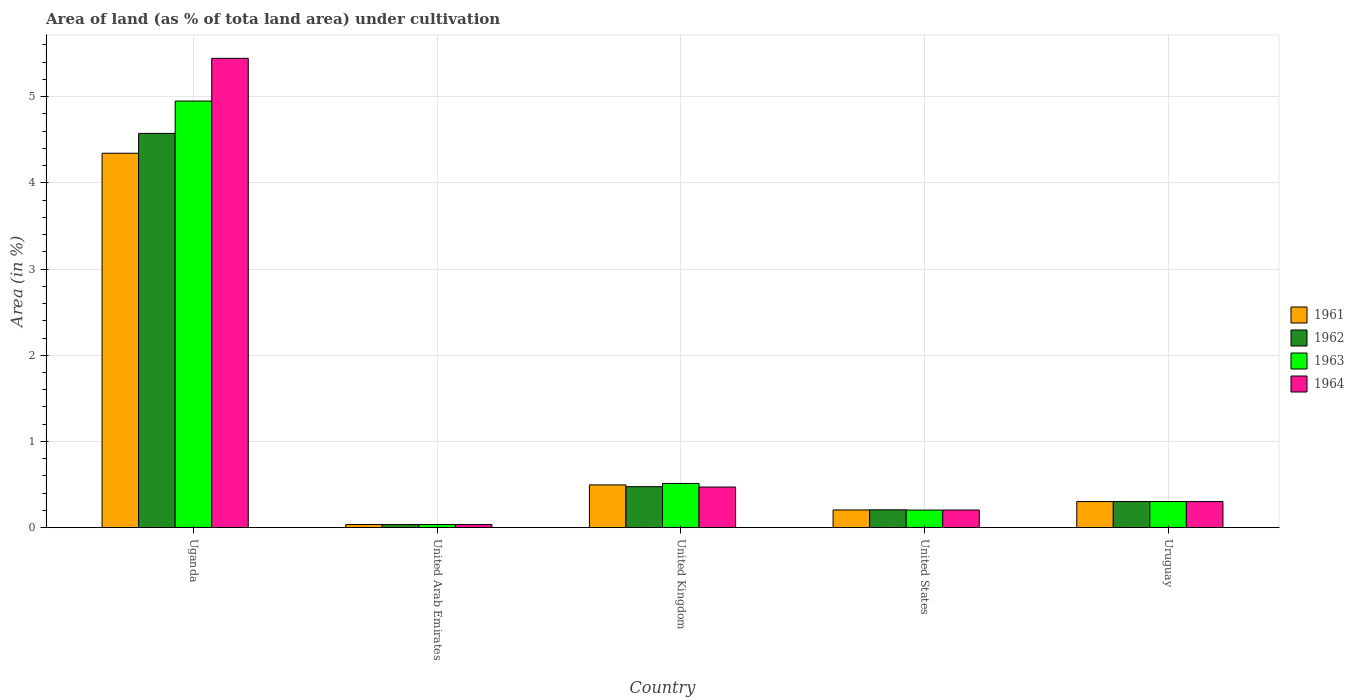How many different coloured bars are there?
Provide a short and direct response. 4. How many groups of bars are there?
Ensure brevity in your answer.  5. Are the number of bars per tick equal to the number of legend labels?
Offer a terse response. Yes. Are the number of bars on each tick of the X-axis equal?
Offer a very short reply. Yes. How many bars are there on the 3rd tick from the left?
Your answer should be compact. 4. What is the label of the 5th group of bars from the left?
Offer a terse response. Uruguay. In how many cases, is the number of bars for a given country not equal to the number of legend labels?
Ensure brevity in your answer.  0. What is the percentage of land under cultivation in 1963 in United Arab Emirates?
Your answer should be compact. 0.04. Across all countries, what is the maximum percentage of land under cultivation in 1963?
Offer a very short reply. 4.95. Across all countries, what is the minimum percentage of land under cultivation in 1964?
Provide a short and direct response. 0.04. In which country was the percentage of land under cultivation in 1962 maximum?
Provide a short and direct response. Uganda. In which country was the percentage of land under cultivation in 1962 minimum?
Make the answer very short. United Arab Emirates. What is the total percentage of land under cultivation in 1964 in the graph?
Offer a very short reply. 6.46. What is the difference between the percentage of land under cultivation in 1964 in Uganda and that in Uruguay?
Keep it short and to the point. 5.14. What is the difference between the percentage of land under cultivation in 1961 in Uganda and the percentage of land under cultivation in 1963 in United States?
Provide a succinct answer. 4.14. What is the average percentage of land under cultivation in 1964 per country?
Your answer should be compact. 1.29. In how many countries, is the percentage of land under cultivation in 1961 greater than 4.8 %?
Ensure brevity in your answer.  0. What is the ratio of the percentage of land under cultivation in 1964 in United Kingdom to that in Uruguay?
Provide a succinct answer. 1.56. Is the percentage of land under cultivation in 1963 in Uganda less than that in United States?
Provide a succinct answer. No. Is the difference between the percentage of land under cultivation in 1962 in Uganda and United Kingdom greater than the difference between the percentage of land under cultivation in 1964 in Uganda and United Kingdom?
Your response must be concise. No. What is the difference between the highest and the second highest percentage of land under cultivation in 1962?
Ensure brevity in your answer.  0.17. What is the difference between the highest and the lowest percentage of land under cultivation in 1961?
Keep it short and to the point. 4.31. Is the sum of the percentage of land under cultivation in 1962 in United Arab Emirates and United Kingdom greater than the maximum percentage of land under cultivation in 1963 across all countries?
Your answer should be very brief. No. What does the 2nd bar from the left in United Kingdom represents?
Make the answer very short. 1962. What does the 1st bar from the right in United States represents?
Provide a succinct answer. 1964. How many bars are there?
Your answer should be very brief. 20. How many legend labels are there?
Your answer should be compact. 4. How are the legend labels stacked?
Keep it short and to the point. Vertical. What is the title of the graph?
Your answer should be very brief. Area of land (as % of tota land area) under cultivation. Does "1976" appear as one of the legend labels in the graph?
Offer a very short reply. No. What is the label or title of the X-axis?
Ensure brevity in your answer.  Country. What is the label or title of the Y-axis?
Keep it short and to the point. Area (in %). What is the Area (in %) in 1961 in Uganda?
Give a very brief answer. 4.34. What is the Area (in %) in 1962 in Uganda?
Your answer should be very brief. 4.57. What is the Area (in %) in 1963 in Uganda?
Your answer should be compact. 4.95. What is the Area (in %) in 1964 in Uganda?
Your response must be concise. 5.45. What is the Area (in %) of 1961 in United Arab Emirates?
Give a very brief answer. 0.04. What is the Area (in %) of 1962 in United Arab Emirates?
Provide a short and direct response. 0.04. What is the Area (in %) of 1963 in United Arab Emirates?
Give a very brief answer. 0.04. What is the Area (in %) in 1964 in United Arab Emirates?
Offer a terse response. 0.04. What is the Area (in %) of 1961 in United Kingdom?
Your answer should be very brief. 0.5. What is the Area (in %) in 1962 in United Kingdom?
Provide a succinct answer. 0.48. What is the Area (in %) in 1963 in United Kingdom?
Ensure brevity in your answer.  0.51. What is the Area (in %) of 1964 in United Kingdom?
Keep it short and to the point. 0.47. What is the Area (in %) in 1961 in United States?
Your answer should be very brief. 0.21. What is the Area (in %) of 1962 in United States?
Your answer should be compact. 0.21. What is the Area (in %) in 1963 in United States?
Give a very brief answer. 0.2. What is the Area (in %) of 1964 in United States?
Offer a terse response. 0.2. What is the Area (in %) of 1961 in Uruguay?
Your answer should be compact. 0.3. What is the Area (in %) of 1962 in Uruguay?
Offer a terse response. 0.3. What is the Area (in %) of 1963 in Uruguay?
Make the answer very short. 0.3. What is the Area (in %) in 1964 in Uruguay?
Give a very brief answer. 0.3. Across all countries, what is the maximum Area (in %) in 1961?
Provide a succinct answer. 4.34. Across all countries, what is the maximum Area (in %) of 1962?
Your response must be concise. 4.57. Across all countries, what is the maximum Area (in %) of 1963?
Provide a short and direct response. 4.95. Across all countries, what is the maximum Area (in %) in 1964?
Offer a terse response. 5.45. Across all countries, what is the minimum Area (in %) of 1961?
Give a very brief answer. 0.04. Across all countries, what is the minimum Area (in %) in 1962?
Give a very brief answer. 0.04. Across all countries, what is the minimum Area (in %) of 1963?
Provide a succinct answer. 0.04. Across all countries, what is the minimum Area (in %) of 1964?
Provide a succinct answer. 0.04. What is the total Area (in %) of 1961 in the graph?
Keep it short and to the point. 5.38. What is the total Area (in %) in 1962 in the graph?
Offer a very short reply. 5.6. What is the total Area (in %) of 1963 in the graph?
Provide a succinct answer. 6. What is the total Area (in %) of 1964 in the graph?
Your response must be concise. 6.46. What is the difference between the Area (in %) of 1961 in Uganda and that in United Arab Emirates?
Your answer should be compact. 4.31. What is the difference between the Area (in %) in 1962 in Uganda and that in United Arab Emirates?
Your answer should be very brief. 4.54. What is the difference between the Area (in %) in 1963 in Uganda and that in United Arab Emirates?
Provide a short and direct response. 4.91. What is the difference between the Area (in %) in 1964 in Uganda and that in United Arab Emirates?
Provide a succinct answer. 5.41. What is the difference between the Area (in %) in 1961 in Uganda and that in United Kingdom?
Provide a short and direct response. 3.85. What is the difference between the Area (in %) in 1962 in Uganda and that in United Kingdom?
Ensure brevity in your answer.  4.1. What is the difference between the Area (in %) in 1963 in Uganda and that in United Kingdom?
Your response must be concise. 4.44. What is the difference between the Area (in %) in 1964 in Uganda and that in United Kingdom?
Give a very brief answer. 4.97. What is the difference between the Area (in %) of 1961 in Uganda and that in United States?
Your answer should be very brief. 4.14. What is the difference between the Area (in %) in 1962 in Uganda and that in United States?
Your response must be concise. 4.37. What is the difference between the Area (in %) in 1963 in Uganda and that in United States?
Your response must be concise. 4.75. What is the difference between the Area (in %) in 1964 in Uganda and that in United States?
Provide a short and direct response. 5.24. What is the difference between the Area (in %) of 1961 in Uganda and that in Uruguay?
Keep it short and to the point. 4.04. What is the difference between the Area (in %) of 1962 in Uganda and that in Uruguay?
Your answer should be compact. 4.27. What is the difference between the Area (in %) of 1963 in Uganda and that in Uruguay?
Offer a very short reply. 4.65. What is the difference between the Area (in %) in 1964 in Uganda and that in Uruguay?
Your answer should be very brief. 5.14. What is the difference between the Area (in %) of 1961 in United Arab Emirates and that in United Kingdom?
Offer a very short reply. -0.46. What is the difference between the Area (in %) in 1962 in United Arab Emirates and that in United Kingdom?
Your answer should be compact. -0.44. What is the difference between the Area (in %) of 1963 in United Arab Emirates and that in United Kingdom?
Your answer should be compact. -0.48. What is the difference between the Area (in %) in 1964 in United Arab Emirates and that in United Kingdom?
Provide a succinct answer. -0.44. What is the difference between the Area (in %) of 1961 in United Arab Emirates and that in United States?
Your answer should be very brief. -0.17. What is the difference between the Area (in %) of 1962 in United Arab Emirates and that in United States?
Give a very brief answer. -0.17. What is the difference between the Area (in %) of 1963 in United Arab Emirates and that in United States?
Your answer should be compact. -0.17. What is the difference between the Area (in %) in 1964 in United Arab Emirates and that in United States?
Give a very brief answer. -0.17. What is the difference between the Area (in %) in 1961 in United Arab Emirates and that in Uruguay?
Your response must be concise. -0.27. What is the difference between the Area (in %) in 1962 in United Arab Emirates and that in Uruguay?
Ensure brevity in your answer.  -0.27. What is the difference between the Area (in %) of 1963 in United Arab Emirates and that in Uruguay?
Your answer should be compact. -0.27. What is the difference between the Area (in %) of 1964 in United Arab Emirates and that in Uruguay?
Provide a short and direct response. -0.27. What is the difference between the Area (in %) in 1961 in United Kingdom and that in United States?
Give a very brief answer. 0.29. What is the difference between the Area (in %) in 1962 in United Kingdom and that in United States?
Keep it short and to the point. 0.27. What is the difference between the Area (in %) of 1963 in United Kingdom and that in United States?
Your response must be concise. 0.31. What is the difference between the Area (in %) in 1964 in United Kingdom and that in United States?
Give a very brief answer. 0.27. What is the difference between the Area (in %) of 1961 in United Kingdom and that in Uruguay?
Provide a succinct answer. 0.19. What is the difference between the Area (in %) in 1962 in United Kingdom and that in Uruguay?
Your answer should be compact. 0.17. What is the difference between the Area (in %) in 1963 in United Kingdom and that in Uruguay?
Ensure brevity in your answer.  0.21. What is the difference between the Area (in %) of 1964 in United Kingdom and that in Uruguay?
Your answer should be compact. 0.17. What is the difference between the Area (in %) of 1961 in United States and that in Uruguay?
Offer a very short reply. -0.1. What is the difference between the Area (in %) in 1962 in United States and that in Uruguay?
Provide a succinct answer. -0.1. What is the difference between the Area (in %) of 1963 in United States and that in Uruguay?
Make the answer very short. -0.1. What is the difference between the Area (in %) in 1964 in United States and that in Uruguay?
Make the answer very short. -0.1. What is the difference between the Area (in %) in 1961 in Uganda and the Area (in %) in 1962 in United Arab Emirates?
Your answer should be very brief. 4.31. What is the difference between the Area (in %) in 1961 in Uganda and the Area (in %) in 1963 in United Arab Emirates?
Make the answer very short. 4.31. What is the difference between the Area (in %) of 1961 in Uganda and the Area (in %) of 1964 in United Arab Emirates?
Provide a short and direct response. 4.31. What is the difference between the Area (in %) of 1962 in Uganda and the Area (in %) of 1963 in United Arab Emirates?
Your response must be concise. 4.54. What is the difference between the Area (in %) of 1962 in Uganda and the Area (in %) of 1964 in United Arab Emirates?
Make the answer very short. 4.54. What is the difference between the Area (in %) in 1963 in Uganda and the Area (in %) in 1964 in United Arab Emirates?
Ensure brevity in your answer.  4.91. What is the difference between the Area (in %) of 1961 in Uganda and the Area (in %) of 1962 in United Kingdom?
Keep it short and to the point. 3.87. What is the difference between the Area (in %) in 1961 in Uganda and the Area (in %) in 1963 in United Kingdom?
Provide a short and direct response. 3.83. What is the difference between the Area (in %) of 1961 in Uganda and the Area (in %) of 1964 in United Kingdom?
Provide a succinct answer. 3.87. What is the difference between the Area (in %) in 1962 in Uganda and the Area (in %) in 1963 in United Kingdom?
Your answer should be very brief. 4.06. What is the difference between the Area (in %) in 1962 in Uganda and the Area (in %) in 1964 in United Kingdom?
Provide a succinct answer. 4.1. What is the difference between the Area (in %) of 1963 in Uganda and the Area (in %) of 1964 in United Kingdom?
Offer a terse response. 4.48. What is the difference between the Area (in %) of 1961 in Uganda and the Area (in %) of 1962 in United States?
Offer a terse response. 4.14. What is the difference between the Area (in %) of 1961 in Uganda and the Area (in %) of 1963 in United States?
Provide a succinct answer. 4.14. What is the difference between the Area (in %) in 1961 in Uganda and the Area (in %) in 1964 in United States?
Provide a succinct answer. 4.14. What is the difference between the Area (in %) of 1962 in Uganda and the Area (in %) of 1963 in United States?
Give a very brief answer. 4.37. What is the difference between the Area (in %) of 1962 in Uganda and the Area (in %) of 1964 in United States?
Your response must be concise. 4.37. What is the difference between the Area (in %) of 1963 in Uganda and the Area (in %) of 1964 in United States?
Provide a short and direct response. 4.75. What is the difference between the Area (in %) of 1961 in Uganda and the Area (in %) of 1962 in Uruguay?
Your answer should be very brief. 4.04. What is the difference between the Area (in %) in 1961 in Uganda and the Area (in %) in 1963 in Uruguay?
Ensure brevity in your answer.  4.04. What is the difference between the Area (in %) of 1961 in Uganda and the Area (in %) of 1964 in Uruguay?
Provide a short and direct response. 4.04. What is the difference between the Area (in %) in 1962 in Uganda and the Area (in %) in 1963 in Uruguay?
Ensure brevity in your answer.  4.27. What is the difference between the Area (in %) of 1962 in Uganda and the Area (in %) of 1964 in Uruguay?
Give a very brief answer. 4.27. What is the difference between the Area (in %) of 1963 in Uganda and the Area (in %) of 1964 in Uruguay?
Ensure brevity in your answer.  4.65. What is the difference between the Area (in %) of 1961 in United Arab Emirates and the Area (in %) of 1962 in United Kingdom?
Your answer should be compact. -0.44. What is the difference between the Area (in %) in 1961 in United Arab Emirates and the Area (in %) in 1963 in United Kingdom?
Provide a short and direct response. -0.48. What is the difference between the Area (in %) in 1961 in United Arab Emirates and the Area (in %) in 1964 in United Kingdom?
Offer a very short reply. -0.44. What is the difference between the Area (in %) in 1962 in United Arab Emirates and the Area (in %) in 1963 in United Kingdom?
Your response must be concise. -0.48. What is the difference between the Area (in %) of 1962 in United Arab Emirates and the Area (in %) of 1964 in United Kingdom?
Provide a short and direct response. -0.44. What is the difference between the Area (in %) in 1963 in United Arab Emirates and the Area (in %) in 1964 in United Kingdom?
Provide a succinct answer. -0.44. What is the difference between the Area (in %) in 1961 in United Arab Emirates and the Area (in %) in 1962 in United States?
Your answer should be very brief. -0.17. What is the difference between the Area (in %) in 1961 in United Arab Emirates and the Area (in %) in 1963 in United States?
Provide a short and direct response. -0.17. What is the difference between the Area (in %) of 1961 in United Arab Emirates and the Area (in %) of 1964 in United States?
Your response must be concise. -0.17. What is the difference between the Area (in %) of 1962 in United Arab Emirates and the Area (in %) of 1963 in United States?
Provide a short and direct response. -0.17. What is the difference between the Area (in %) of 1962 in United Arab Emirates and the Area (in %) of 1964 in United States?
Make the answer very short. -0.17. What is the difference between the Area (in %) of 1963 in United Arab Emirates and the Area (in %) of 1964 in United States?
Make the answer very short. -0.17. What is the difference between the Area (in %) in 1961 in United Arab Emirates and the Area (in %) in 1962 in Uruguay?
Offer a terse response. -0.27. What is the difference between the Area (in %) in 1961 in United Arab Emirates and the Area (in %) in 1963 in Uruguay?
Ensure brevity in your answer.  -0.27. What is the difference between the Area (in %) of 1961 in United Arab Emirates and the Area (in %) of 1964 in Uruguay?
Your answer should be compact. -0.27. What is the difference between the Area (in %) in 1962 in United Arab Emirates and the Area (in %) in 1963 in Uruguay?
Your answer should be compact. -0.27. What is the difference between the Area (in %) of 1962 in United Arab Emirates and the Area (in %) of 1964 in Uruguay?
Your answer should be compact. -0.27. What is the difference between the Area (in %) in 1963 in United Arab Emirates and the Area (in %) in 1964 in Uruguay?
Give a very brief answer. -0.27. What is the difference between the Area (in %) of 1961 in United Kingdom and the Area (in %) of 1962 in United States?
Offer a very short reply. 0.29. What is the difference between the Area (in %) in 1961 in United Kingdom and the Area (in %) in 1963 in United States?
Provide a short and direct response. 0.29. What is the difference between the Area (in %) in 1961 in United Kingdom and the Area (in %) in 1964 in United States?
Ensure brevity in your answer.  0.29. What is the difference between the Area (in %) in 1962 in United Kingdom and the Area (in %) in 1963 in United States?
Your response must be concise. 0.27. What is the difference between the Area (in %) in 1962 in United Kingdom and the Area (in %) in 1964 in United States?
Your answer should be very brief. 0.27. What is the difference between the Area (in %) of 1963 in United Kingdom and the Area (in %) of 1964 in United States?
Provide a succinct answer. 0.31. What is the difference between the Area (in %) of 1961 in United Kingdom and the Area (in %) of 1962 in Uruguay?
Your answer should be very brief. 0.19. What is the difference between the Area (in %) of 1961 in United Kingdom and the Area (in %) of 1963 in Uruguay?
Keep it short and to the point. 0.19. What is the difference between the Area (in %) in 1961 in United Kingdom and the Area (in %) in 1964 in Uruguay?
Make the answer very short. 0.19. What is the difference between the Area (in %) in 1962 in United Kingdom and the Area (in %) in 1963 in Uruguay?
Offer a terse response. 0.17. What is the difference between the Area (in %) in 1962 in United Kingdom and the Area (in %) in 1964 in Uruguay?
Provide a succinct answer. 0.17. What is the difference between the Area (in %) in 1963 in United Kingdom and the Area (in %) in 1964 in Uruguay?
Your answer should be very brief. 0.21. What is the difference between the Area (in %) of 1961 in United States and the Area (in %) of 1962 in Uruguay?
Ensure brevity in your answer.  -0.1. What is the difference between the Area (in %) of 1961 in United States and the Area (in %) of 1963 in Uruguay?
Your answer should be compact. -0.1. What is the difference between the Area (in %) of 1961 in United States and the Area (in %) of 1964 in Uruguay?
Provide a short and direct response. -0.1. What is the difference between the Area (in %) in 1962 in United States and the Area (in %) in 1963 in Uruguay?
Keep it short and to the point. -0.1. What is the difference between the Area (in %) in 1962 in United States and the Area (in %) in 1964 in Uruguay?
Offer a terse response. -0.1. What is the difference between the Area (in %) in 1963 in United States and the Area (in %) in 1964 in Uruguay?
Provide a succinct answer. -0.1. What is the average Area (in %) of 1961 per country?
Provide a short and direct response. 1.08. What is the average Area (in %) of 1962 per country?
Your answer should be very brief. 1.12. What is the average Area (in %) of 1963 per country?
Provide a short and direct response. 1.2. What is the average Area (in %) of 1964 per country?
Your answer should be compact. 1.29. What is the difference between the Area (in %) in 1961 and Area (in %) in 1962 in Uganda?
Make the answer very short. -0.23. What is the difference between the Area (in %) in 1961 and Area (in %) in 1963 in Uganda?
Give a very brief answer. -0.61. What is the difference between the Area (in %) of 1961 and Area (in %) of 1964 in Uganda?
Make the answer very short. -1.1. What is the difference between the Area (in %) of 1962 and Area (in %) of 1963 in Uganda?
Provide a short and direct response. -0.38. What is the difference between the Area (in %) of 1962 and Area (in %) of 1964 in Uganda?
Your response must be concise. -0.87. What is the difference between the Area (in %) in 1963 and Area (in %) in 1964 in Uganda?
Give a very brief answer. -0.5. What is the difference between the Area (in %) in 1961 and Area (in %) in 1964 in United Arab Emirates?
Offer a very short reply. 0. What is the difference between the Area (in %) of 1962 and Area (in %) of 1963 in United Arab Emirates?
Offer a very short reply. 0. What is the difference between the Area (in %) of 1961 and Area (in %) of 1962 in United Kingdom?
Provide a succinct answer. 0.02. What is the difference between the Area (in %) of 1961 and Area (in %) of 1963 in United Kingdom?
Your answer should be very brief. -0.02. What is the difference between the Area (in %) in 1961 and Area (in %) in 1964 in United Kingdom?
Make the answer very short. 0.02. What is the difference between the Area (in %) of 1962 and Area (in %) of 1963 in United Kingdom?
Give a very brief answer. -0.04. What is the difference between the Area (in %) in 1962 and Area (in %) in 1964 in United Kingdom?
Make the answer very short. 0. What is the difference between the Area (in %) in 1963 and Area (in %) in 1964 in United Kingdom?
Provide a short and direct response. 0.04. What is the difference between the Area (in %) in 1961 and Area (in %) in 1962 in United States?
Offer a terse response. -0. What is the difference between the Area (in %) of 1961 and Area (in %) of 1963 in United States?
Provide a succinct answer. 0. What is the difference between the Area (in %) of 1961 and Area (in %) of 1964 in United States?
Provide a short and direct response. 0. What is the difference between the Area (in %) of 1962 and Area (in %) of 1963 in United States?
Make the answer very short. 0. What is the difference between the Area (in %) in 1962 and Area (in %) in 1964 in United States?
Keep it short and to the point. 0. What is the difference between the Area (in %) in 1963 and Area (in %) in 1964 in United States?
Provide a succinct answer. -0. What is the difference between the Area (in %) in 1962 and Area (in %) in 1964 in Uruguay?
Your response must be concise. 0. What is the ratio of the Area (in %) of 1961 in Uganda to that in United Arab Emirates?
Your answer should be very brief. 121.06. What is the ratio of the Area (in %) in 1962 in Uganda to that in United Arab Emirates?
Provide a succinct answer. 127.47. What is the ratio of the Area (in %) of 1963 in Uganda to that in United Arab Emirates?
Give a very brief answer. 137.93. What is the ratio of the Area (in %) of 1964 in Uganda to that in United Arab Emirates?
Your response must be concise. 151.74. What is the ratio of the Area (in %) of 1961 in Uganda to that in United Kingdom?
Make the answer very short. 8.76. What is the ratio of the Area (in %) of 1962 in Uganda to that in United Kingdom?
Keep it short and to the point. 9.62. What is the ratio of the Area (in %) of 1963 in Uganda to that in United Kingdom?
Provide a succinct answer. 9.66. What is the ratio of the Area (in %) in 1964 in Uganda to that in United Kingdom?
Make the answer very short. 11.56. What is the ratio of the Area (in %) in 1961 in Uganda to that in United States?
Offer a terse response. 21.17. What is the ratio of the Area (in %) of 1962 in Uganda to that in United States?
Keep it short and to the point. 22.1. What is the ratio of the Area (in %) in 1963 in Uganda to that in United States?
Offer a terse response. 24.26. What is the ratio of the Area (in %) of 1964 in Uganda to that in United States?
Provide a short and direct response. 26.63. What is the ratio of the Area (in %) of 1961 in Uganda to that in Uruguay?
Your response must be concise. 14.35. What is the ratio of the Area (in %) of 1962 in Uganda to that in Uruguay?
Your answer should be compact. 15.11. What is the ratio of the Area (in %) in 1963 in Uganda to that in Uruguay?
Provide a succinct answer. 16.35. What is the ratio of the Area (in %) of 1964 in Uganda to that in Uruguay?
Provide a succinct answer. 17.98. What is the ratio of the Area (in %) of 1961 in United Arab Emirates to that in United Kingdom?
Ensure brevity in your answer.  0.07. What is the ratio of the Area (in %) of 1962 in United Arab Emirates to that in United Kingdom?
Offer a very short reply. 0.08. What is the ratio of the Area (in %) in 1963 in United Arab Emirates to that in United Kingdom?
Keep it short and to the point. 0.07. What is the ratio of the Area (in %) of 1964 in United Arab Emirates to that in United Kingdom?
Your response must be concise. 0.08. What is the ratio of the Area (in %) of 1961 in United Arab Emirates to that in United States?
Offer a very short reply. 0.17. What is the ratio of the Area (in %) in 1962 in United Arab Emirates to that in United States?
Ensure brevity in your answer.  0.17. What is the ratio of the Area (in %) of 1963 in United Arab Emirates to that in United States?
Make the answer very short. 0.18. What is the ratio of the Area (in %) of 1964 in United Arab Emirates to that in United States?
Offer a terse response. 0.18. What is the ratio of the Area (in %) in 1961 in United Arab Emirates to that in Uruguay?
Provide a short and direct response. 0.12. What is the ratio of the Area (in %) of 1962 in United Arab Emirates to that in Uruguay?
Provide a succinct answer. 0.12. What is the ratio of the Area (in %) in 1963 in United Arab Emirates to that in Uruguay?
Provide a short and direct response. 0.12. What is the ratio of the Area (in %) in 1964 in United Arab Emirates to that in Uruguay?
Offer a very short reply. 0.12. What is the ratio of the Area (in %) of 1961 in United Kingdom to that in United States?
Keep it short and to the point. 2.42. What is the ratio of the Area (in %) in 1962 in United Kingdom to that in United States?
Ensure brevity in your answer.  2.3. What is the ratio of the Area (in %) of 1963 in United Kingdom to that in United States?
Give a very brief answer. 2.51. What is the ratio of the Area (in %) of 1964 in United Kingdom to that in United States?
Give a very brief answer. 2.3. What is the ratio of the Area (in %) in 1961 in United Kingdom to that in Uruguay?
Make the answer very short. 1.64. What is the ratio of the Area (in %) of 1962 in United Kingdom to that in Uruguay?
Ensure brevity in your answer.  1.57. What is the ratio of the Area (in %) of 1963 in United Kingdom to that in Uruguay?
Offer a very short reply. 1.69. What is the ratio of the Area (in %) of 1964 in United Kingdom to that in Uruguay?
Provide a short and direct response. 1.56. What is the ratio of the Area (in %) in 1961 in United States to that in Uruguay?
Your answer should be compact. 0.68. What is the ratio of the Area (in %) of 1962 in United States to that in Uruguay?
Offer a very short reply. 0.68. What is the ratio of the Area (in %) in 1963 in United States to that in Uruguay?
Your answer should be very brief. 0.67. What is the ratio of the Area (in %) of 1964 in United States to that in Uruguay?
Provide a succinct answer. 0.68. What is the difference between the highest and the second highest Area (in %) in 1961?
Provide a succinct answer. 3.85. What is the difference between the highest and the second highest Area (in %) of 1962?
Ensure brevity in your answer.  4.1. What is the difference between the highest and the second highest Area (in %) in 1963?
Offer a very short reply. 4.44. What is the difference between the highest and the second highest Area (in %) of 1964?
Offer a very short reply. 4.97. What is the difference between the highest and the lowest Area (in %) of 1961?
Offer a very short reply. 4.31. What is the difference between the highest and the lowest Area (in %) in 1962?
Offer a very short reply. 4.54. What is the difference between the highest and the lowest Area (in %) in 1963?
Ensure brevity in your answer.  4.91. What is the difference between the highest and the lowest Area (in %) in 1964?
Offer a terse response. 5.41. 